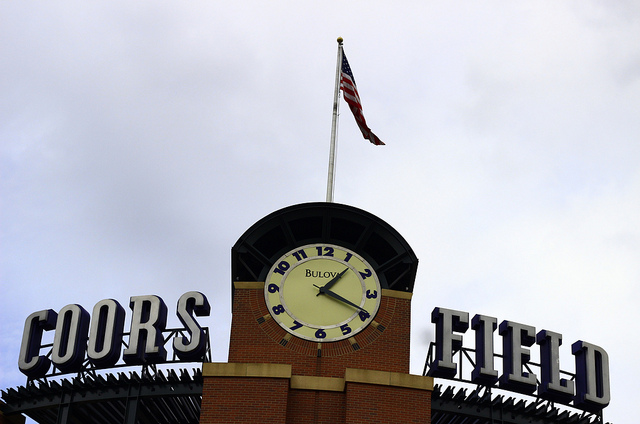Read and extract the text from this image. BULOVA COORS FIELD 12 1 10 11 2 3 4 5 6 7 8 6 